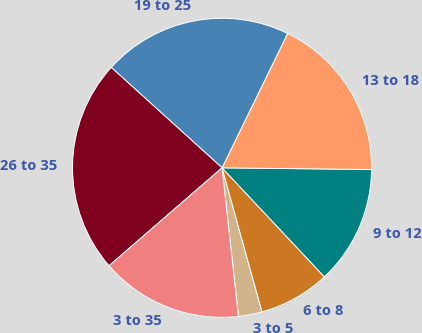Convert chart. <chart><loc_0><loc_0><loc_500><loc_500><pie_chart><fcel>3 to 5<fcel>6 to 8<fcel>9 to 12<fcel>13 to 18<fcel>19 to 25<fcel>26 to 35<fcel>3 to 35<nl><fcel>2.56%<fcel>7.69%<fcel>12.82%<fcel>17.95%<fcel>20.51%<fcel>23.08%<fcel>15.38%<nl></chart> 